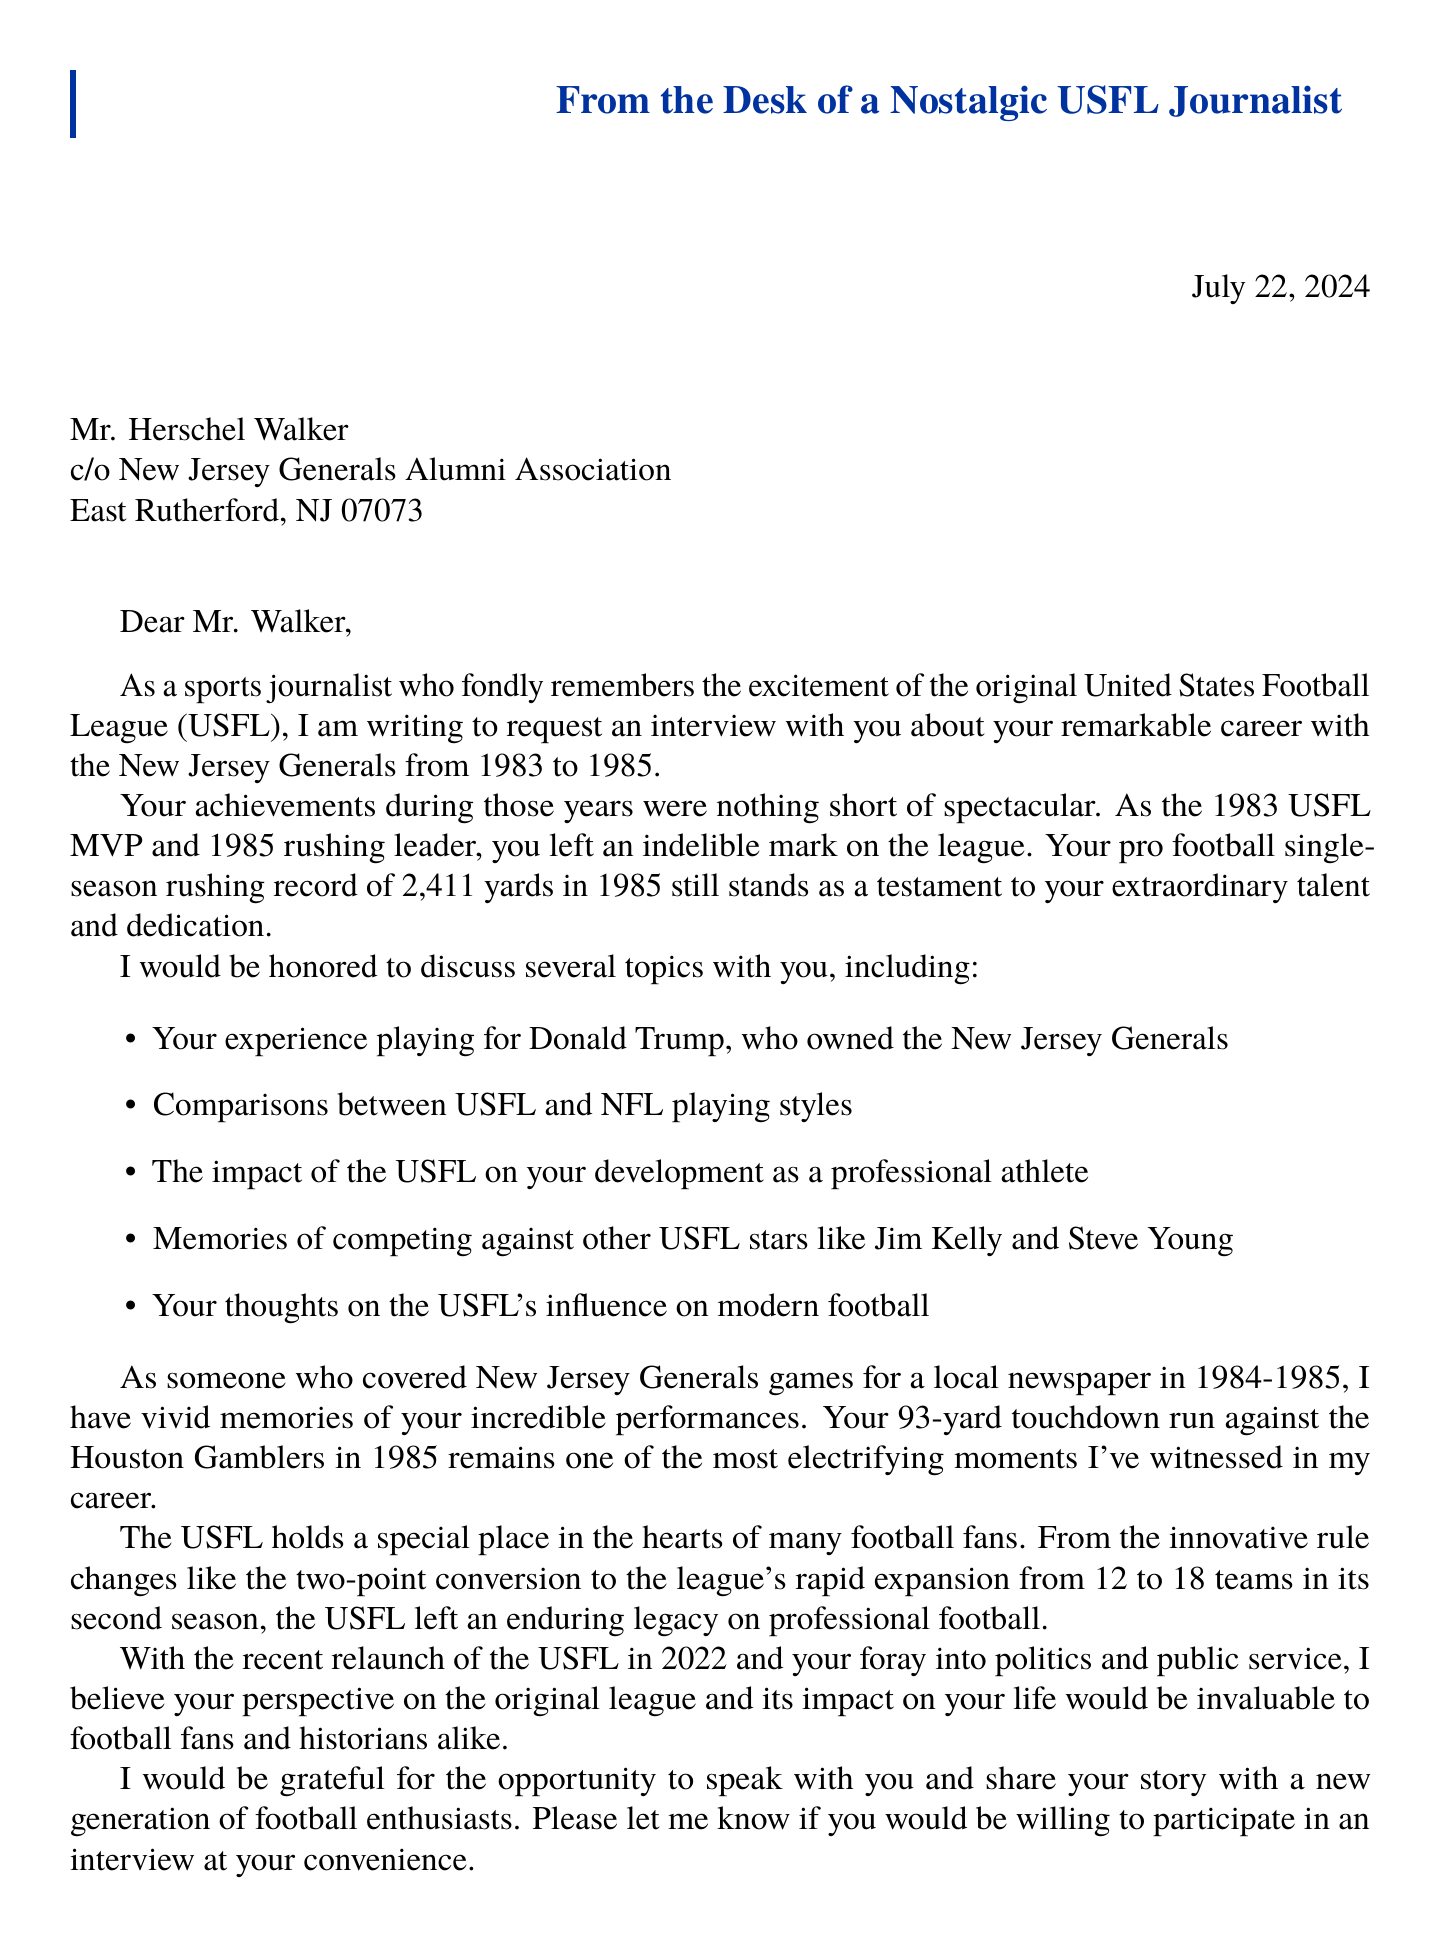What is the purpose of the letter? The purpose of the letter is to request an interview with Herschel Walker about his USFL career.
Answer: Request an interview with Herschel Walker about his USFL career Who did Herschel Walker play for in the USFL? The letter mentions that Herschel Walker played for the New Jersey Generals.
Answer: New Jersey Generals What years did Herschel Walker play in the USFL? The letter states that Herschel Walker played in the USFL from 1983 to 1985.
Answer: 1983-1985 What was one of Herschel Walker's notable achievements in 1983? One notable achievement of Herschel Walker in 1983 was being named the USFL MVP.
Answer: 1983 USFL MVP Which game is highlighted as a memorable moment in the letter? The letter highlights Walker's 93-yard touchdown run against the Houston Gamblers in 1985 as a memorable moment.
Answer: 93-yard touchdown run against the Houston Gamblers What significant record did Herschel Walker set in 1985? The letter mentions that Herschel Walker set a single-season rushing record with 2,411 yards in 1985.
Answer: 2,411 yards in 1985 Who owned the New Jersey Generals during Walker's time? The letter states that Donald Trump owned the New Jersey Generals.
Answer: Donald Trump What innovative rule is mentioned in the letter? The letter references the two-point conversion as an innovative rule introduced by the USFL.
Answer: Two-point conversion What event does the letter mention attending in 1985? It mentions attending the 1985 USFL Championship game between the Baltimore Stars and Oakland Invaders.
Answer: 1985 USFL Championship game What is a current relevance mentioned in the letter? The letter mentions the relaunch of the USFL in 2022 as a current relevance.
Answer: The 2022 relaunch of the USFL 